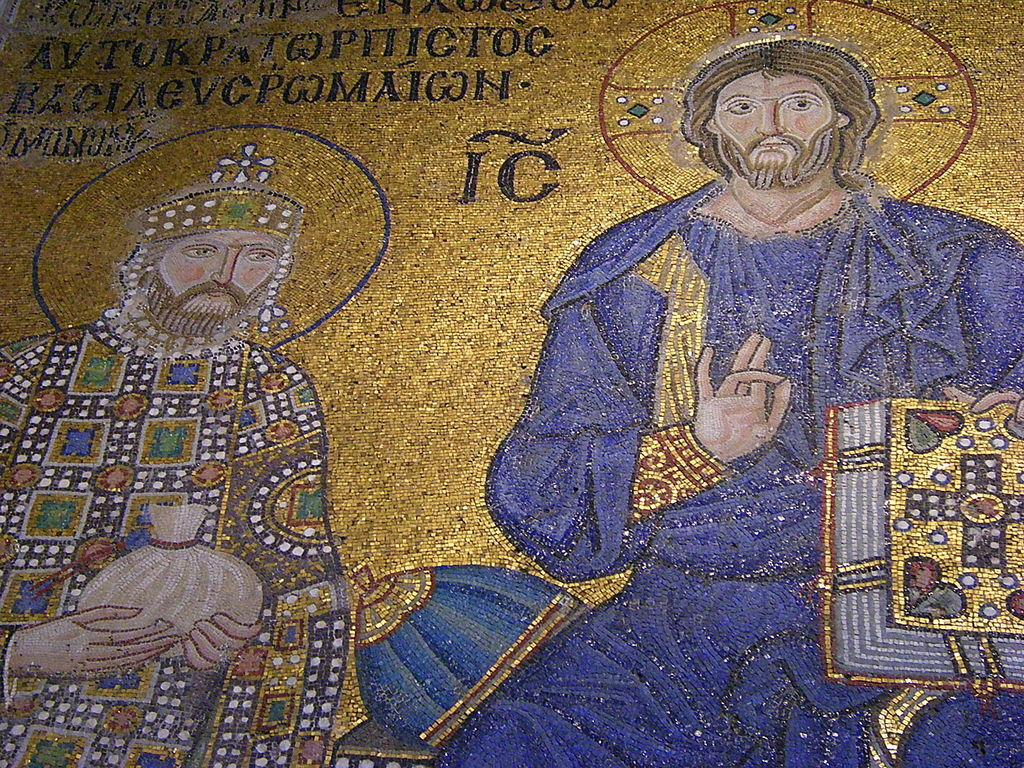What is the main subject of the image? There is a painting in the image. What else can be seen on the wall in the image? There are words on the wall in the image. Where is the card located in the image? There is no card present in the image. What type of honey can be seen dripping from the painting in the image? There is no honey present in the image; it only features a painting and words on the wall. 